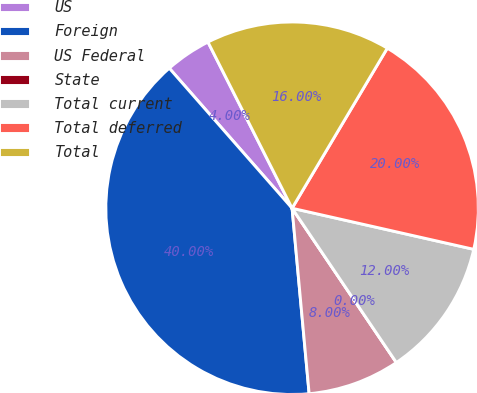Convert chart. <chart><loc_0><loc_0><loc_500><loc_500><pie_chart><fcel>US<fcel>Foreign<fcel>US Federal<fcel>State<fcel>Total current<fcel>Total deferred<fcel>Total<nl><fcel>4.0%<fcel>40.0%<fcel>8.0%<fcel>0.0%<fcel>12.0%<fcel>20.0%<fcel>16.0%<nl></chart> 